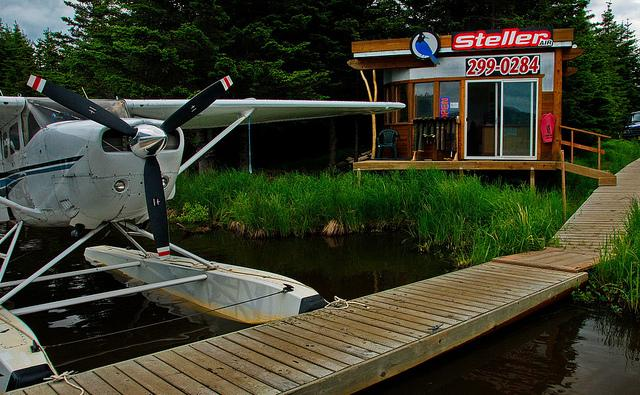What rhymes with the name of the store and is found on the vehicle?

Choices:
A) trunk
B) hood
C) door
D) propeller propeller 